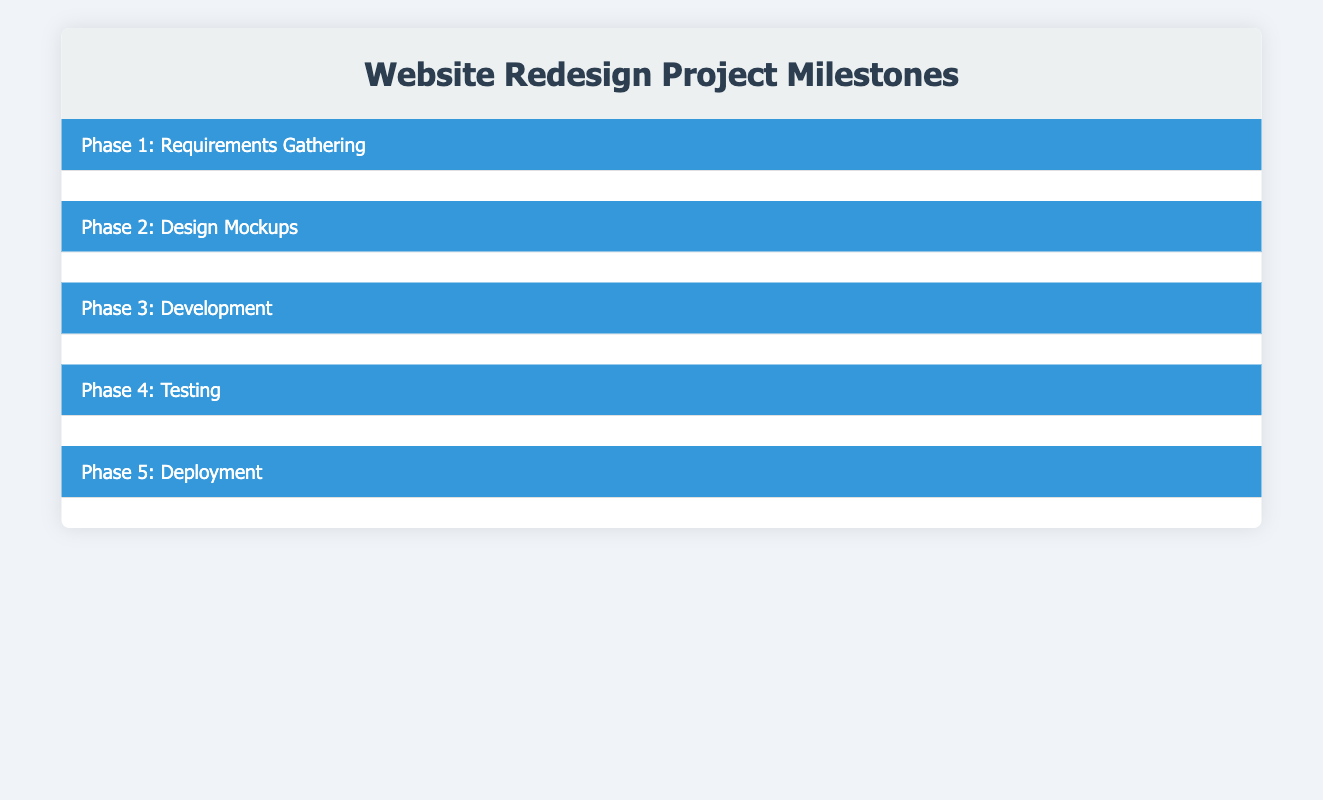What is the status of the task "Create requirements documentation"? The task "Create requirements documentation" is assigned to Bob Smith, and its status listed in the table is "In Progress."
Answer: In Progress Who is responsible for the task "Design homepage mockup"? The task "Design homepage mockup" is assigned to Charlie Brown, as stated in the table under Phase 2.
Answer: Charlie Brown How many tasks are assigned to Alice Johnson? Alice Johnson is assigned to three tasks: "Conduct stakeholder interviews," "Review design with stakeholders," and "Prepare deployment plan," which totals to three tasks.
Answer: 3 Is the task "Set up Git repository" completed? Yes, the task "Set up Git repository" is marked as "Completed" in the table under Phase 3.
Answer: Yes What is the due date for the "Conduct usability testing" task? The due date for the task "Conduct usability testing" is listed as "2023-10-15" in the table under Phase 4.
Answer: 2023-10-15 How many tasks are currently not started across all phases? The tasks not started are: "Design homepage mockup," "Review design with stakeholders," "Implement homepage design," "Conduct usability testing," "Fix identified bugs," "Prepare deployment plan," and "Deploy to production server." Counting these gives us a total of seven tasks that are not started.
Answer: 7 Which phase has the most completed tasks? By reviewing the phases, Phase 1 has one completed task ("Conduct stakeholder interviews") and Phase 3 also has one completed task ("Set up Git repository"). Other phases either have no completed tasks or are not started. Therefore, there is a tie in completed tasks between Phase 1 and Phase 3.
Answer: Phase 1 and Phase 3 If Alice Johnson completes her current tasks, how many total tasks will she have completed? Alice Johnson has one completed task ("Conduct stakeholder interviews"). If she completes the other tasks assigned to her, "Review design with stakeholders" and "Prepare deployment plan," she will then have completed three tasks in total.
Answer: 3 